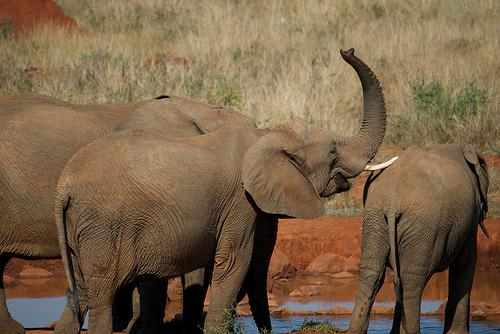Question: how many elephants are there in the picture?
Choices:
A. 2.
B. 8.
C. 3.
D. 4.
Answer with the letter. Answer: C Question: who took the picture?
Choices:
A. Visitor.
B. Customer.
C. Tourist.
D. Stranger.
Answer with the letter. Answer: C Question: what color are the elephants?
Choices:
A. Grey.
B. Brown.
C. Black.
D. Brownish gray.
Answer with the letter. Answer: D 